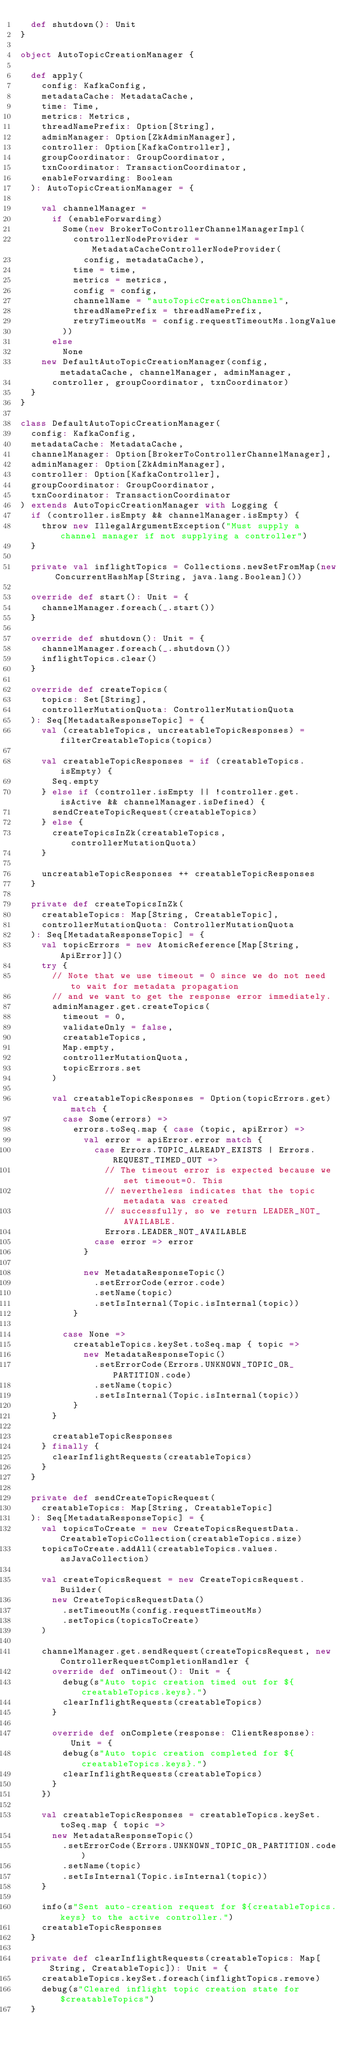Convert code to text. <code><loc_0><loc_0><loc_500><loc_500><_Scala_>  def shutdown(): Unit
}

object AutoTopicCreationManager {

  def apply(
    config: KafkaConfig,
    metadataCache: MetadataCache,
    time: Time,
    metrics: Metrics,
    threadNamePrefix: Option[String],
    adminManager: Option[ZkAdminManager],
    controller: Option[KafkaController],
    groupCoordinator: GroupCoordinator,
    txnCoordinator: TransactionCoordinator,
    enableForwarding: Boolean
  ): AutoTopicCreationManager = {

    val channelManager =
      if (enableForwarding)
        Some(new BrokerToControllerChannelManagerImpl(
          controllerNodeProvider = MetadataCacheControllerNodeProvider(
            config, metadataCache),
          time = time,
          metrics = metrics,
          config = config,
          channelName = "autoTopicCreationChannel",
          threadNamePrefix = threadNamePrefix,
          retryTimeoutMs = config.requestTimeoutMs.longValue
        ))
      else
        None
    new DefaultAutoTopicCreationManager(config, metadataCache, channelManager, adminManager,
      controller, groupCoordinator, txnCoordinator)
  }
}

class DefaultAutoTopicCreationManager(
  config: KafkaConfig,
  metadataCache: MetadataCache,
  channelManager: Option[BrokerToControllerChannelManager],
  adminManager: Option[ZkAdminManager],
  controller: Option[KafkaController],
  groupCoordinator: GroupCoordinator,
  txnCoordinator: TransactionCoordinator
) extends AutoTopicCreationManager with Logging {
  if (controller.isEmpty && channelManager.isEmpty) {
    throw new IllegalArgumentException("Must supply a channel manager if not supplying a controller")
  }

  private val inflightTopics = Collections.newSetFromMap(new ConcurrentHashMap[String, java.lang.Boolean]())

  override def start(): Unit = {
    channelManager.foreach(_.start())
  }

  override def shutdown(): Unit = {
    channelManager.foreach(_.shutdown())
    inflightTopics.clear()
  }

  override def createTopics(
    topics: Set[String],
    controllerMutationQuota: ControllerMutationQuota
  ): Seq[MetadataResponseTopic] = {
    val (creatableTopics, uncreatableTopicResponses) = filterCreatableTopics(topics)

    val creatableTopicResponses = if (creatableTopics.isEmpty) {
      Seq.empty
    } else if (controller.isEmpty || !controller.get.isActive && channelManager.isDefined) {
      sendCreateTopicRequest(creatableTopics)
    } else {
      createTopicsInZk(creatableTopics, controllerMutationQuota)
    }

    uncreatableTopicResponses ++ creatableTopicResponses
  }

  private def createTopicsInZk(
    creatableTopics: Map[String, CreatableTopic],
    controllerMutationQuota: ControllerMutationQuota
  ): Seq[MetadataResponseTopic] = {
    val topicErrors = new AtomicReference[Map[String, ApiError]]()
    try {
      // Note that we use timeout = 0 since we do not need to wait for metadata propagation
      // and we want to get the response error immediately.
      adminManager.get.createTopics(
        timeout = 0,
        validateOnly = false,
        creatableTopics,
        Map.empty,
        controllerMutationQuota,
        topicErrors.set
      )

      val creatableTopicResponses = Option(topicErrors.get) match {
        case Some(errors) =>
          errors.toSeq.map { case (topic, apiError) =>
            val error = apiError.error match {
              case Errors.TOPIC_ALREADY_EXISTS | Errors.REQUEST_TIMED_OUT =>
                // The timeout error is expected because we set timeout=0. This
                // nevertheless indicates that the topic metadata was created
                // successfully, so we return LEADER_NOT_AVAILABLE.
                Errors.LEADER_NOT_AVAILABLE
              case error => error
            }

            new MetadataResponseTopic()
              .setErrorCode(error.code)
              .setName(topic)
              .setIsInternal(Topic.isInternal(topic))
          }

        case None =>
          creatableTopics.keySet.toSeq.map { topic =>
            new MetadataResponseTopic()
              .setErrorCode(Errors.UNKNOWN_TOPIC_OR_PARTITION.code)
              .setName(topic)
              .setIsInternal(Topic.isInternal(topic))
          }
      }

      creatableTopicResponses
    } finally {
      clearInflightRequests(creatableTopics)
    }
  }

  private def sendCreateTopicRequest(
    creatableTopics: Map[String, CreatableTopic]
  ): Seq[MetadataResponseTopic] = {
    val topicsToCreate = new CreateTopicsRequestData.CreatableTopicCollection(creatableTopics.size)
    topicsToCreate.addAll(creatableTopics.values.asJavaCollection)

    val createTopicsRequest = new CreateTopicsRequest.Builder(
      new CreateTopicsRequestData()
        .setTimeoutMs(config.requestTimeoutMs)
        .setTopics(topicsToCreate)
    )

    channelManager.get.sendRequest(createTopicsRequest, new ControllerRequestCompletionHandler {
      override def onTimeout(): Unit = {
        debug(s"Auto topic creation timed out for ${creatableTopics.keys}.")
        clearInflightRequests(creatableTopics)
      }

      override def onComplete(response: ClientResponse): Unit = {
        debug(s"Auto topic creation completed for ${creatableTopics.keys}.")
        clearInflightRequests(creatableTopics)
      }
    })

    val creatableTopicResponses = creatableTopics.keySet.toSeq.map { topic =>
      new MetadataResponseTopic()
        .setErrorCode(Errors.UNKNOWN_TOPIC_OR_PARTITION.code)
        .setName(topic)
        .setIsInternal(Topic.isInternal(topic))
    }

    info(s"Sent auto-creation request for ${creatableTopics.keys} to the active controller.")
    creatableTopicResponses
  }

  private def clearInflightRequests(creatableTopics: Map[String, CreatableTopic]): Unit = {
    creatableTopics.keySet.foreach(inflightTopics.remove)
    debug(s"Cleared inflight topic creation state for $creatableTopics")
  }
</code> 